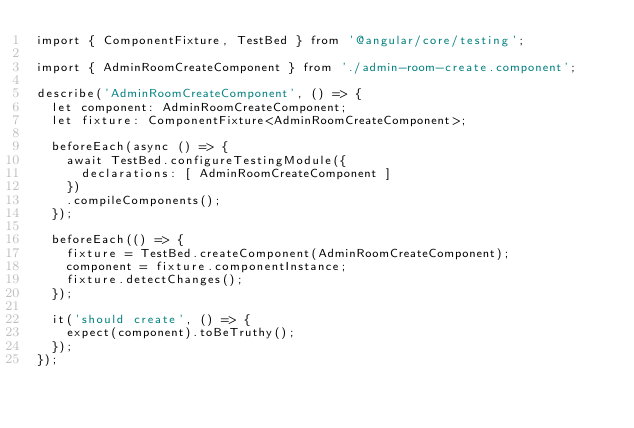<code> <loc_0><loc_0><loc_500><loc_500><_TypeScript_>import { ComponentFixture, TestBed } from '@angular/core/testing';

import { AdminRoomCreateComponent } from './admin-room-create.component';

describe('AdminRoomCreateComponent', () => {
  let component: AdminRoomCreateComponent;
  let fixture: ComponentFixture<AdminRoomCreateComponent>;

  beforeEach(async () => {
    await TestBed.configureTestingModule({
      declarations: [ AdminRoomCreateComponent ]
    })
    .compileComponents();
  });

  beforeEach(() => {
    fixture = TestBed.createComponent(AdminRoomCreateComponent);
    component = fixture.componentInstance;
    fixture.detectChanges();
  });

  it('should create', () => {
    expect(component).toBeTruthy();
  });
});
</code> 